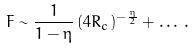Convert formula to latex. <formula><loc_0><loc_0><loc_500><loc_500>F \sim \frac { 1 } { 1 - \eta } \, ( 4 R _ { c } ) ^ { - { \frac { \eta } { 2 } } } + \dots \, .</formula> 